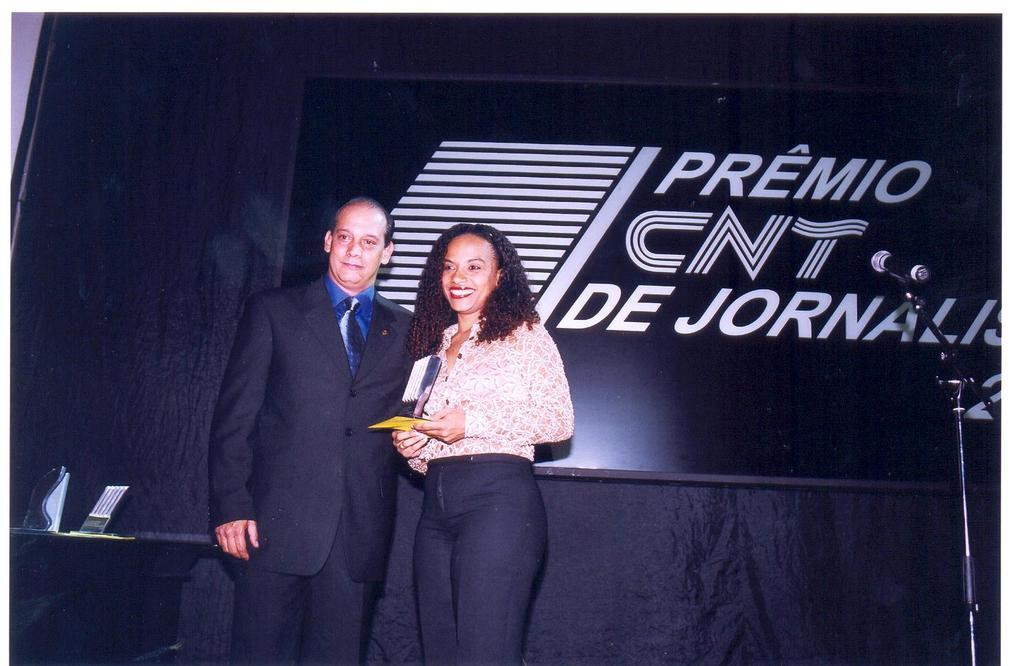Who are the people in the image? There is a man and a woman in the image. Where are they standing? They are standing on a dais. What can be seen on the table in the image? There are mementos on a table in the image. How is the microphone positioned in the image? A microphone is fixed to a stand. What is visible in the background of the image? There is an advertisement visible in the background. What shape is the man's dislike for the woman taking in the image? There is no indication of any dislike or shape in the image; the man and woman are simply standing on a dais. 